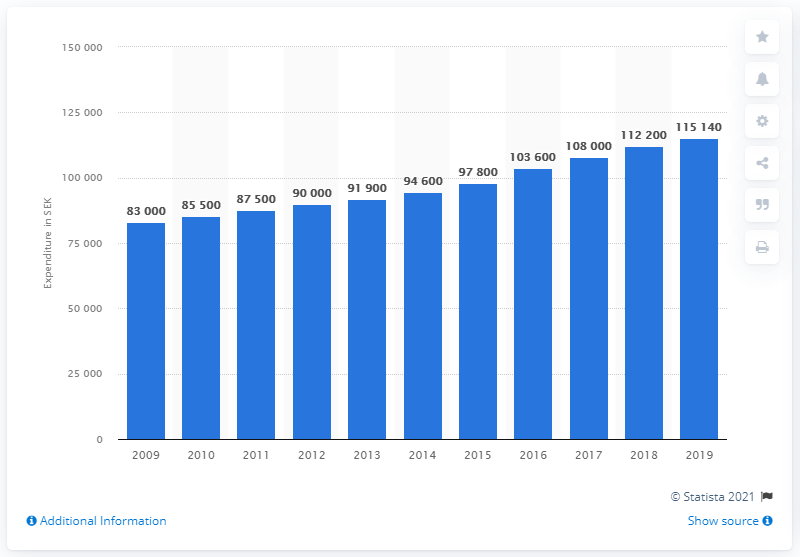Point out several critical features in this image. The expenditure on primary education in Sweden significantly increased in the year 2009. In 2009, it was reported that an average of 83,000 Swedish kronor was spent on each pupil in Sweden. 